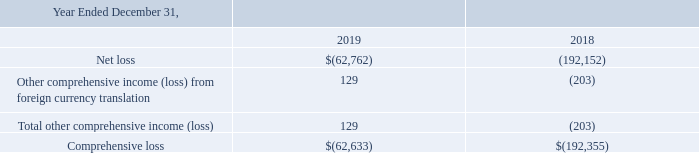NantHealth, Inc
Consolidated Statements of Comprehensive Loss
(Dollars in thousands)
The accompanying notes are an integral part of these Consolidated Financial Statements.
What are the respective net losses made by the company in 2018 and 2019?
Answer scale should be: thousand. 192,152, 62,762. What are the respective comprehensive losses made by the company in 2018 and 2019?
Answer scale should be: thousand. 192,355, 62,633. What is the total other comprehensive loss made by the company in 2018?
Answer scale should be: thousand. 203. What is the average net loss in 2018 and 2019?
Answer scale should be: thousand. (192,152 + 62,762)/2 
Answer: 127457. What is the percentage change in net loss between 2018 and 2019?
Answer scale should be: percent. (62,762 - 192,152)/192,152 
Answer: -67.34. What is the percentage change in comprehensive loss between 2018 and 2019?
Answer scale should be: percent. (62,633 - 192,355)/192,355 
Answer: -67.44. 